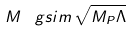<formula> <loc_0><loc_0><loc_500><loc_500>M \, \ g s i m \, \sqrt { M _ { P } \Lambda }</formula> 